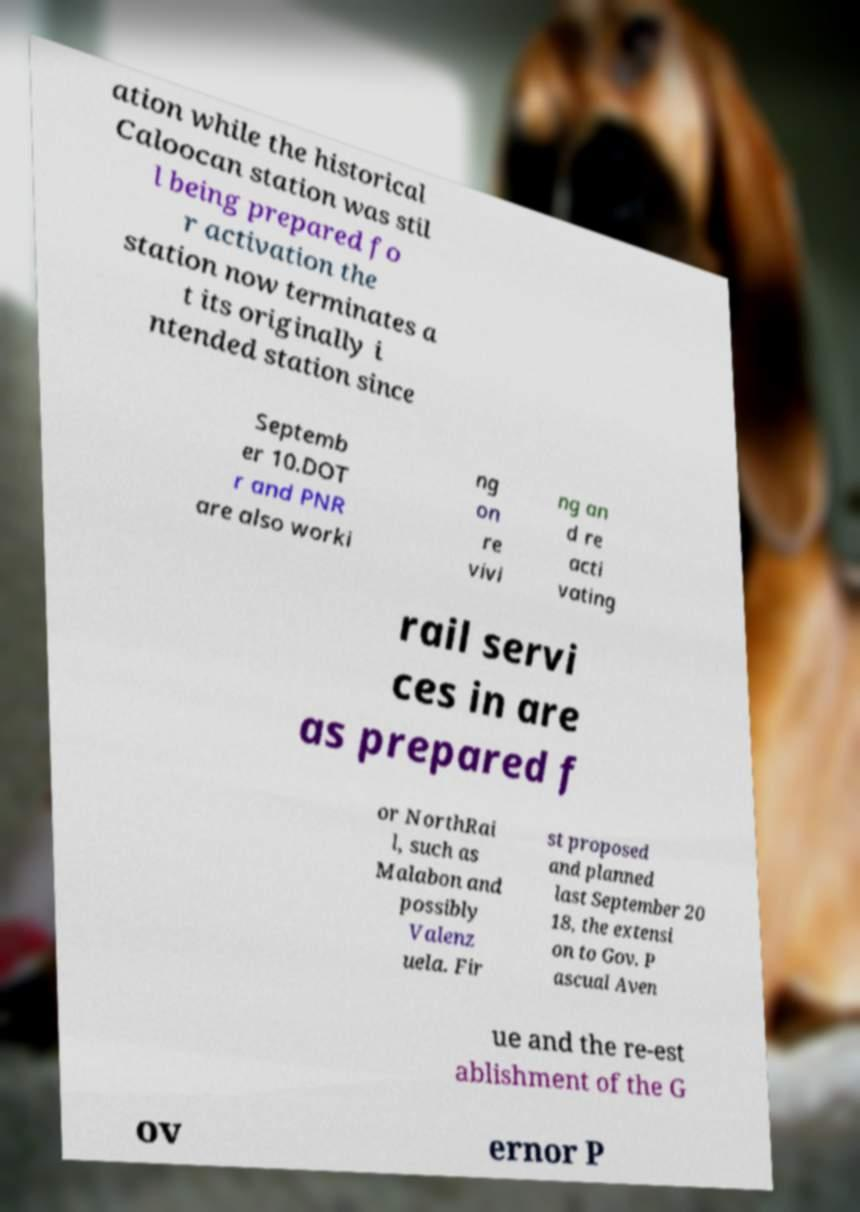What messages or text are displayed in this image? I need them in a readable, typed format. ation while the historical Caloocan station was stil l being prepared fo r activation the station now terminates a t its originally i ntended station since Septemb er 10.DOT r and PNR are also worki ng on re vivi ng an d re acti vating rail servi ces in are as prepared f or NorthRai l, such as Malabon and possibly Valenz uela. Fir st proposed and planned last September 20 18, the extensi on to Gov. P ascual Aven ue and the re-est ablishment of the G ov ernor P 